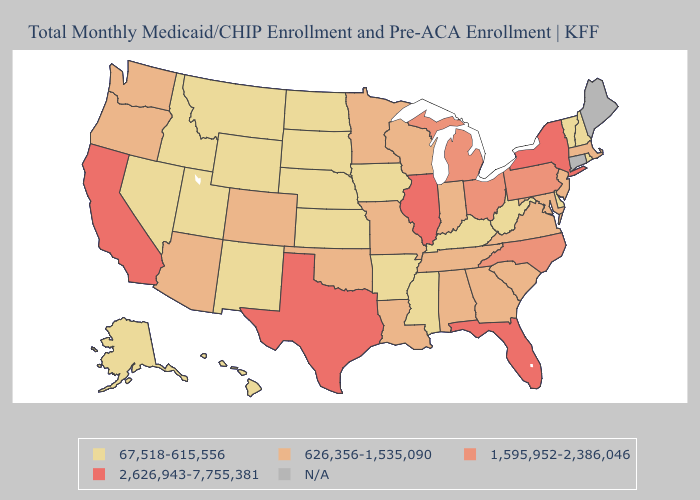Does Vermont have the highest value in the Northeast?
Concise answer only. No. What is the lowest value in the MidWest?
Concise answer only. 67,518-615,556. Among the states that border Oregon , does Nevada have the lowest value?
Concise answer only. Yes. Name the states that have a value in the range 67,518-615,556?
Answer briefly. Alaska, Arkansas, Delaware, Hawaii, Idaho, Iowa, Kansas, Kentucky, Mississippi, Montana, Nebraska, Nevada, New Hampshire, New Mexico, North Dakota, Rhode Island, South Dakota, Utah, Vermont, West Virginia, Wyoming. Among the states that border Oregon , does California have the highest value?
Short answer required. Yes. Name the states that have a value in the range 1,595,952-2,386,046?
Short answer required. Michigan, North Carolina, Ohio, Pennsylvania. Name the states that have a value in the range 626,356-1,535,090?
Quick response, please. Alabama, Arizona, Colorado, Georgia, Indiana, Louisiana, Maryland, Massachusetts, Minnesota, Missouri, New Jersey, Oklahoma, Oregon, South Carolina, Tennessee, Virginia, Washington, Wisconsin. What is the value of Nevada?
Be succinct. 67,518-615,556. What is the highest value in the South ?
Quick response, please. 2,626,943-7,755,381. What is the highest value in the USA?
Short answer required. 2,626,943-7,755,381. What is the value of Minnesota?
Write a very short answer. 626,356-1,535,090. Name the states that have a value in the range 67,518-615,556?
Quick response, please. Alaska, Arkansas, Delaware, Hawaii, Idaho, Iowa, Kansas, Kentucky, Mississippi, Montana, Nebraska, Nevada, New Hampshire, New Mexico, North Dakota, Rhode Island, South Dakota, Utah, Vermont, West Virginia, Wyoming. Name the states that have a value in the range N/A?
Short answer required. Connecticut, Maine. What is the value of Oklahoma?
Quick response, please. 626,356-1,535,090. 